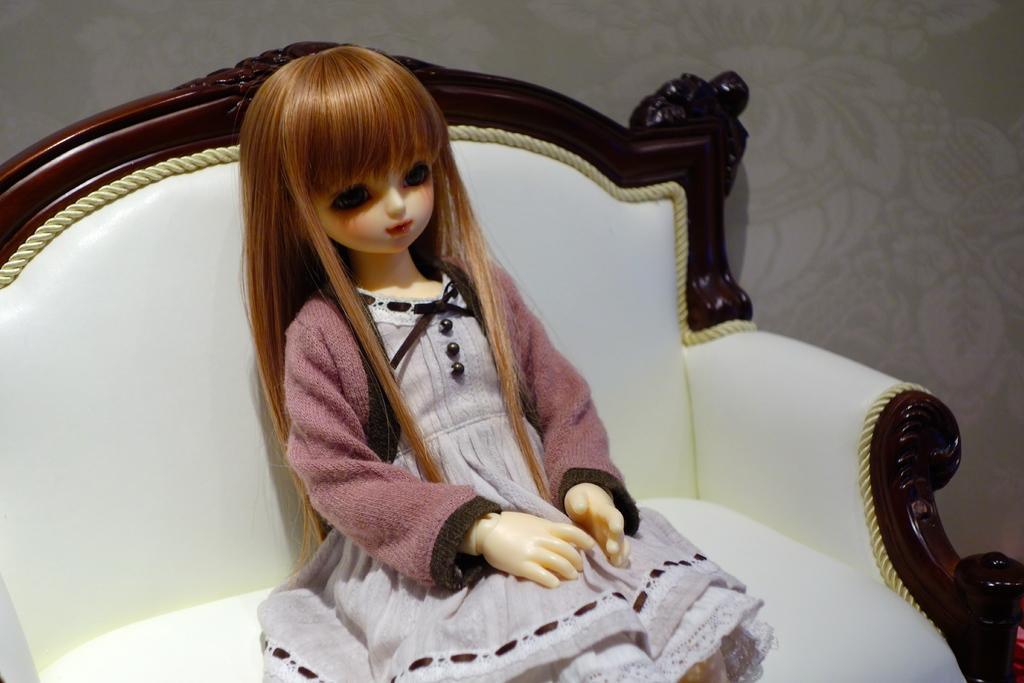Please provide a concise description of this image. In the center of the image we can see a doll is sitting on a chair. In the background of the image we can see the wall. 